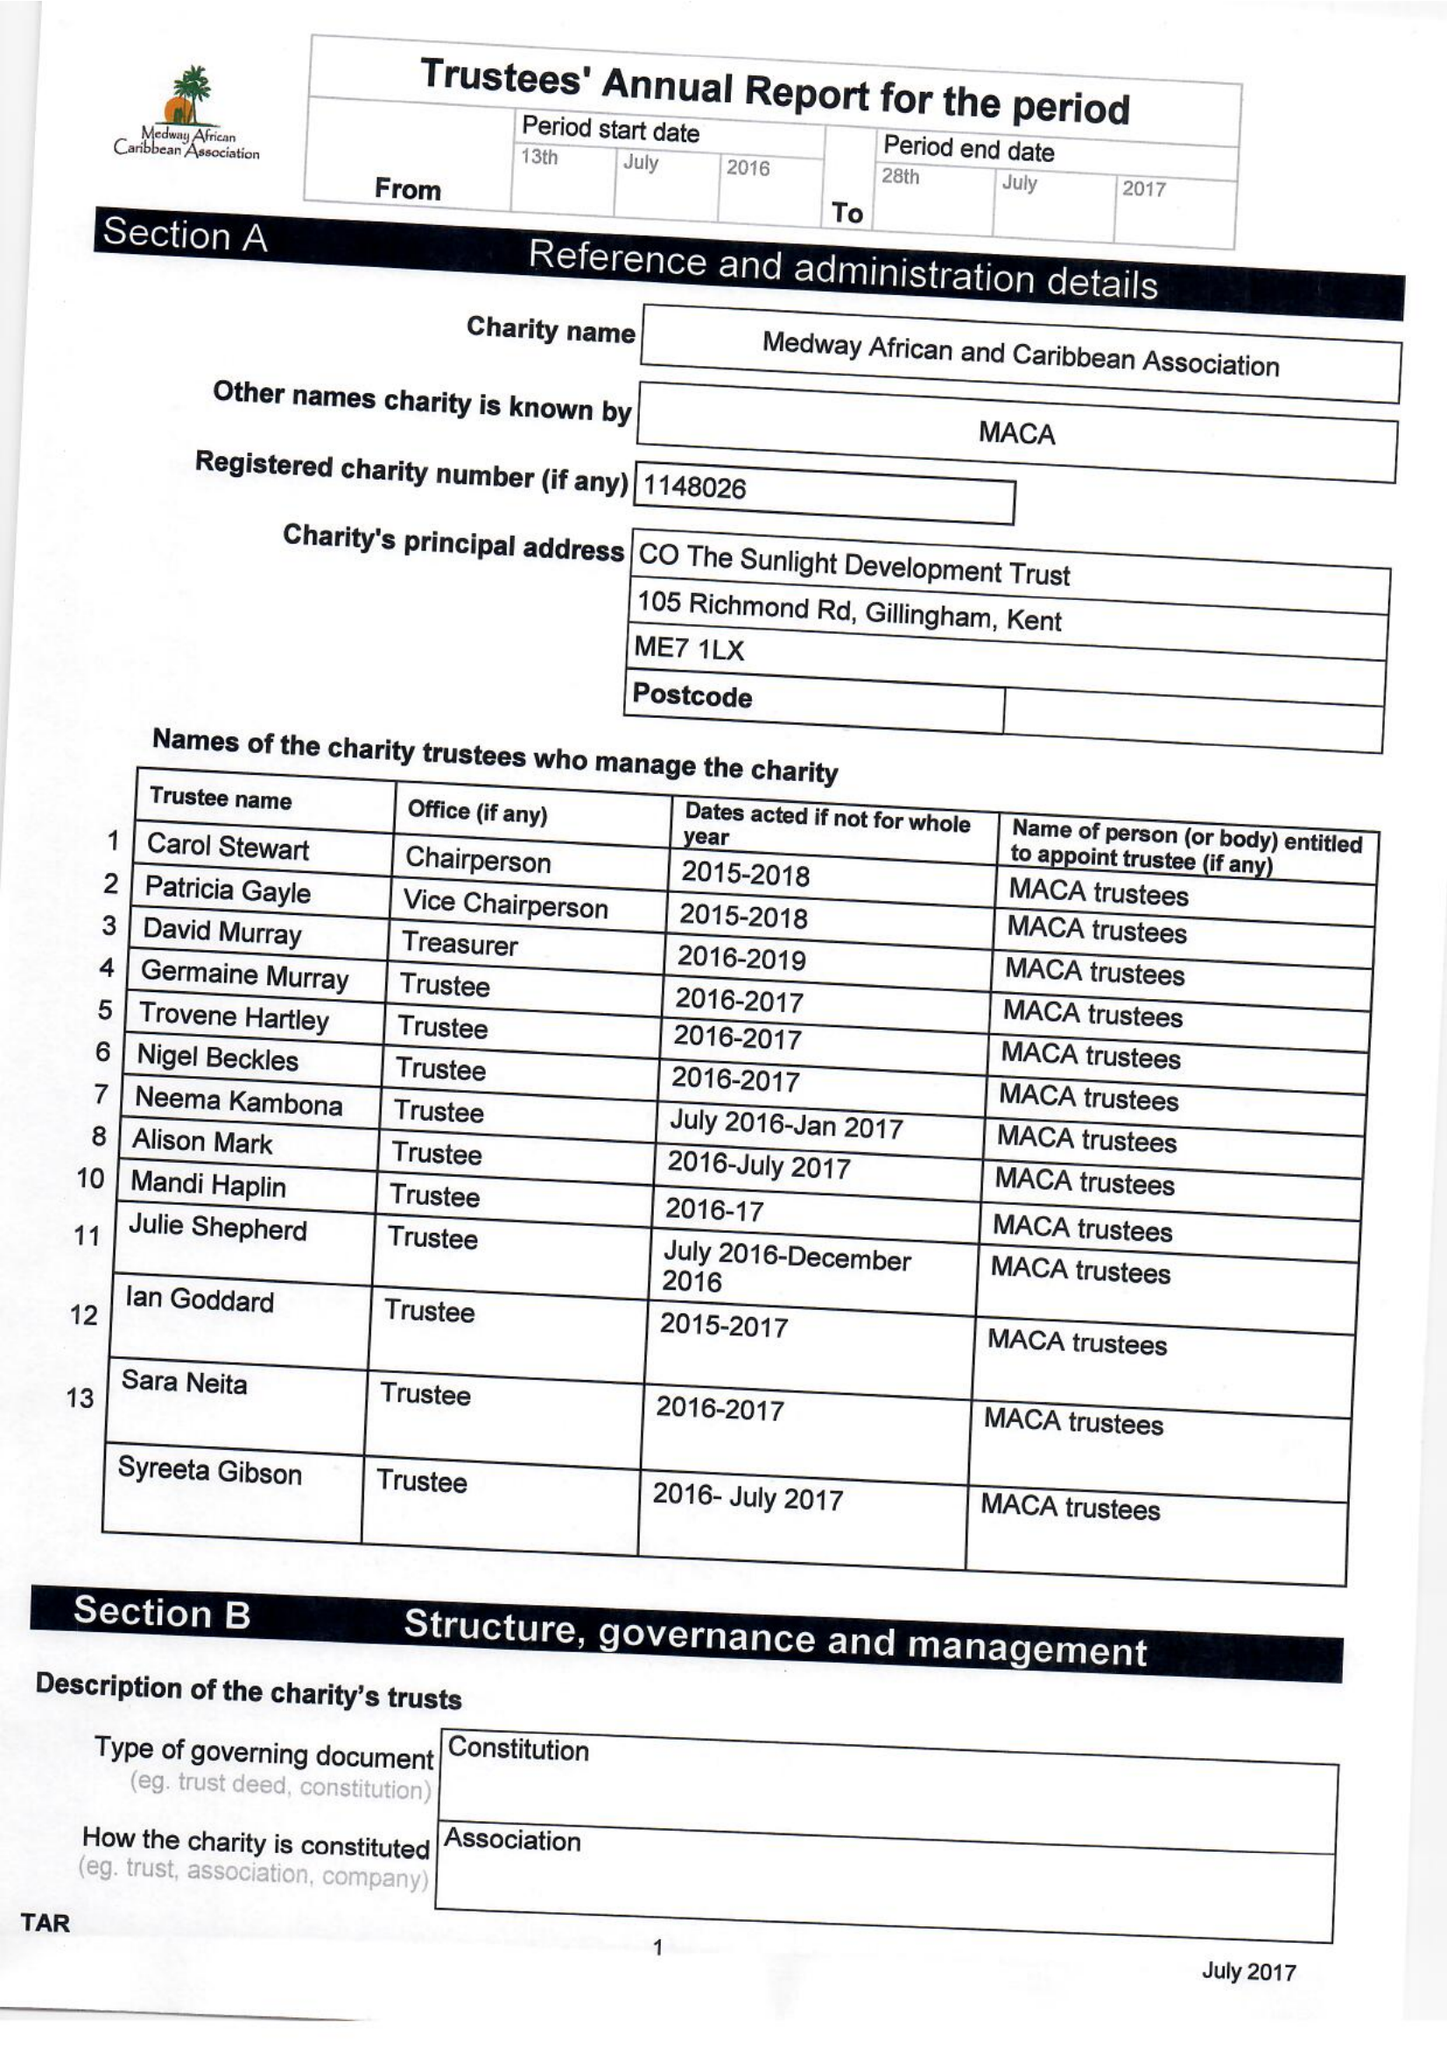What is the value for the charity_number?
Answer the question using a single word or phrase. 1148026 